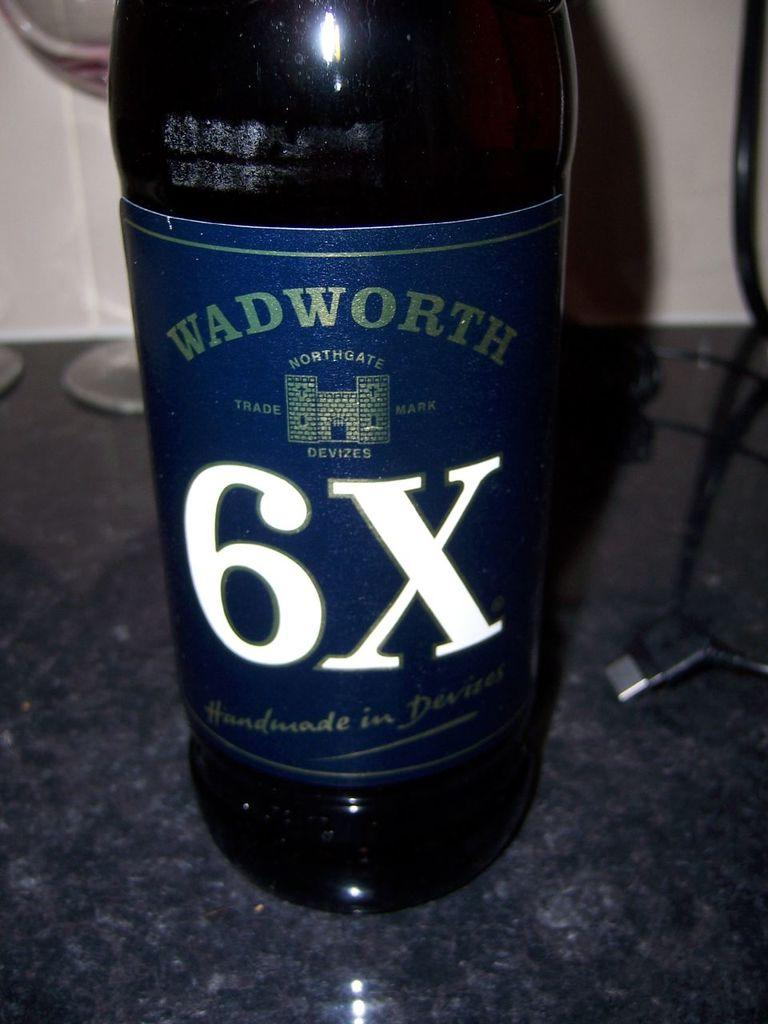<image>
Present a compact description of the photo's key features. Bottle of Wadworth 6x lays on a marble table 